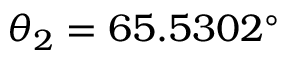<formula> <loc_0><loc_0><loc_500><loc_500>\theta _ { 2 } = 6 5 . 5 3 0 2 ^ { \circ }</formula> 